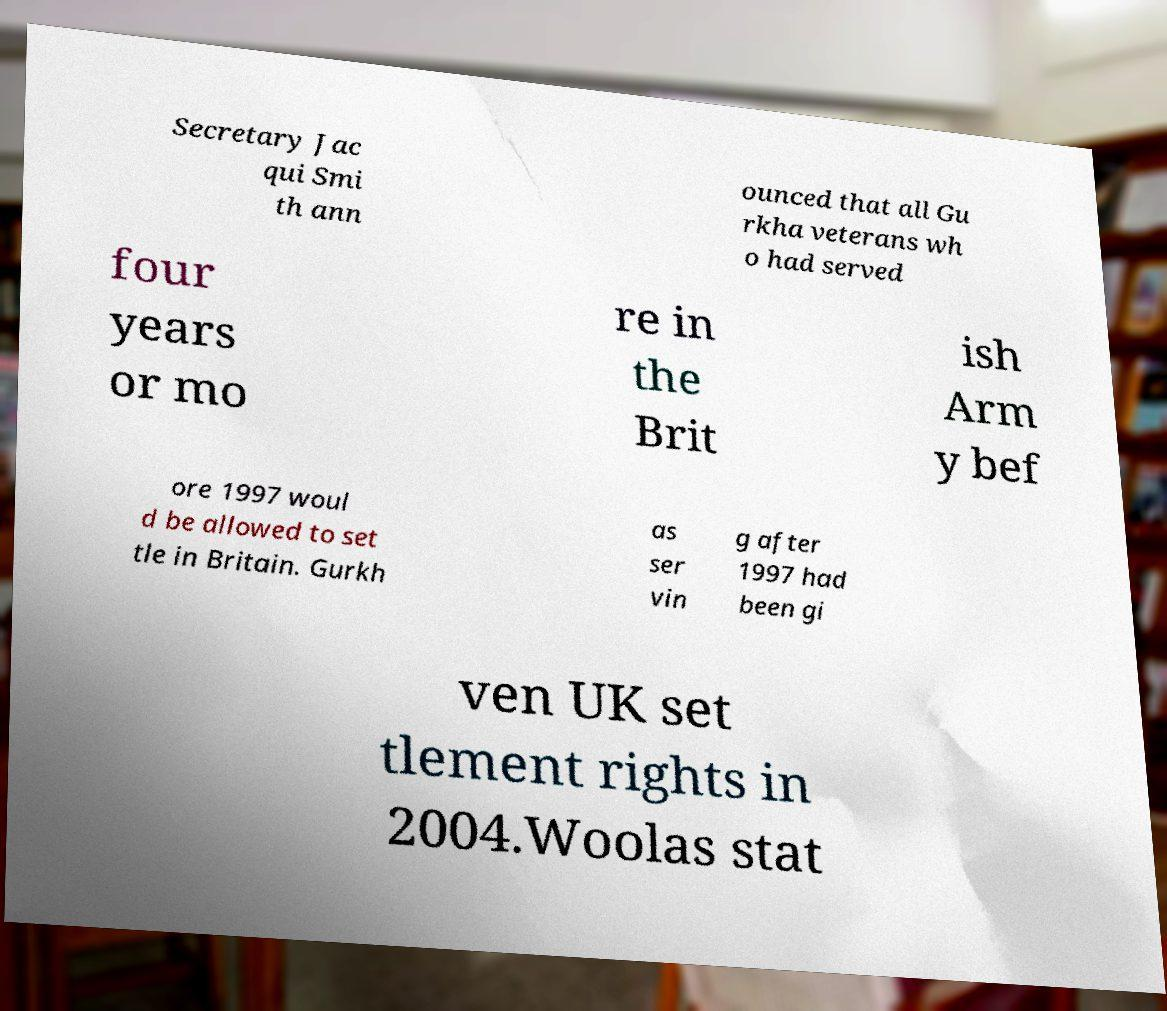Please read and relay the text visible in this image. What does it say? Secretary Jac qui Smi th ann ounced that all Gu rkha veterans wh o had served four years or mo re in the Brit ish Arm y bef ore 1997 woul d be allowed to set tle in Britain. Gurkh as ser vin g after 1997 had been gi ven UK set tlement rights in 2004.Woolas stat 